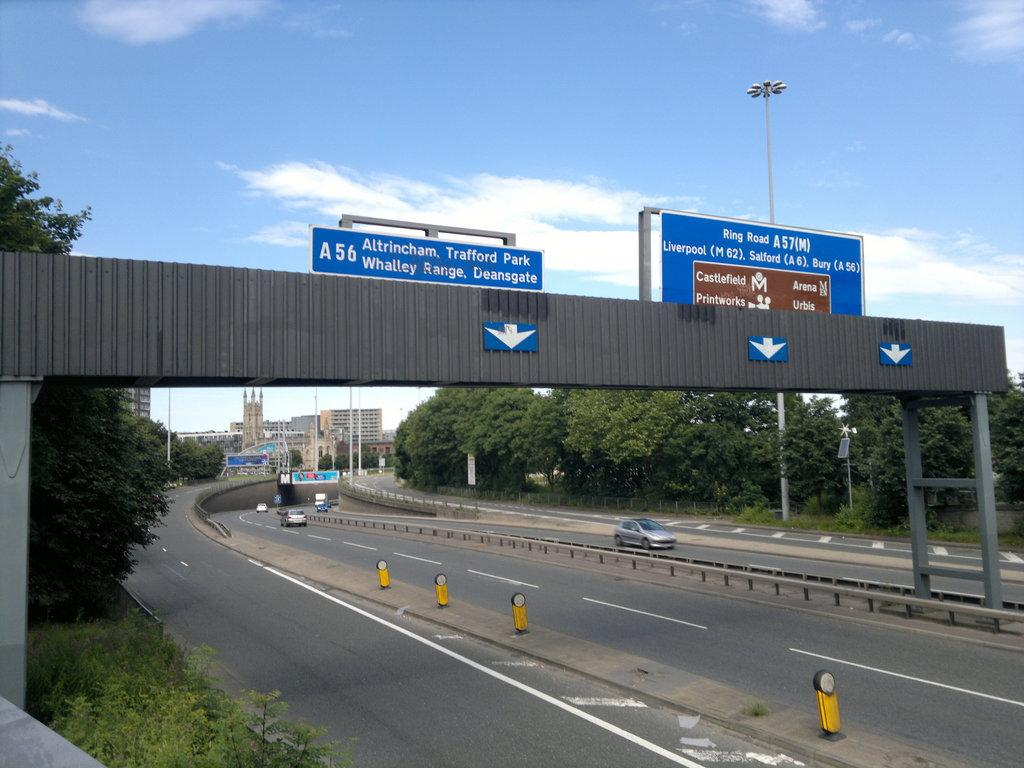Provide a one-sentence caption for the provided image. A freeway where a large sign stretches above the lanes and says Altricham Trafford Park. 